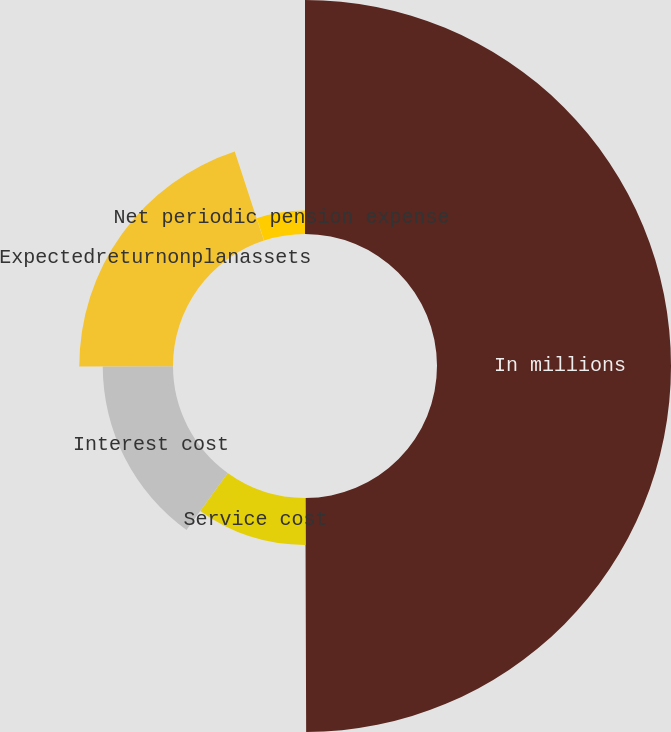Convert chart. <chart><loc_0><loc_0><loc_500><loc_500><pie_chart><fcel>In millions<fcel>Service cost<fcel>Interest cost<fcel>Expectedreturnonplanassets<fcel>Actuarial (gain) loss<fcel>Net periodic pension expense<nl><fcel>49.95%<fcel>10.01%<fcel>15.0%<fcel>20.0%<fcel>0.02%<fcel>5.02%<nl></chart> 